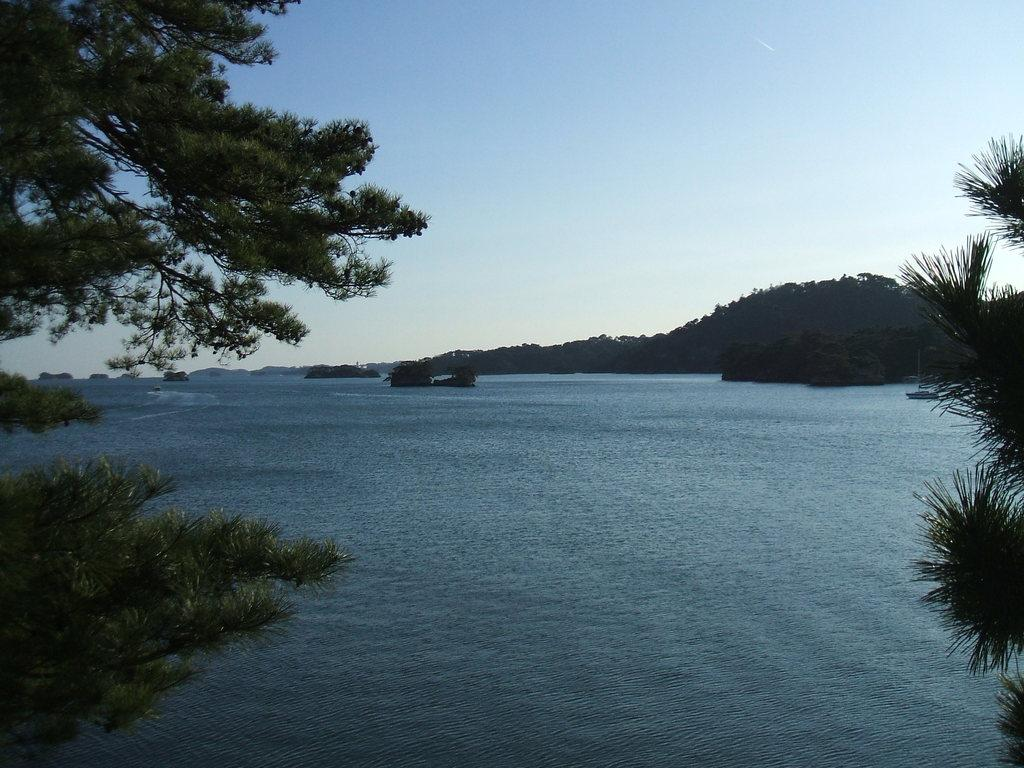What is visible in the image? Water, trees, and hills are visible in the image. Can you describe the natural elements present in the image? The image features water, trees, and hills, which are all natural elements. What type of landscape is depicted in the image? The image shows a landscape with water, trees, and hills. How many times has the water been folded in the image? The water in the image is not folded; it is a natural body of water. What type of love is depicted in the image? There is no depiction of love in the image; it features water, trees, and hills. 